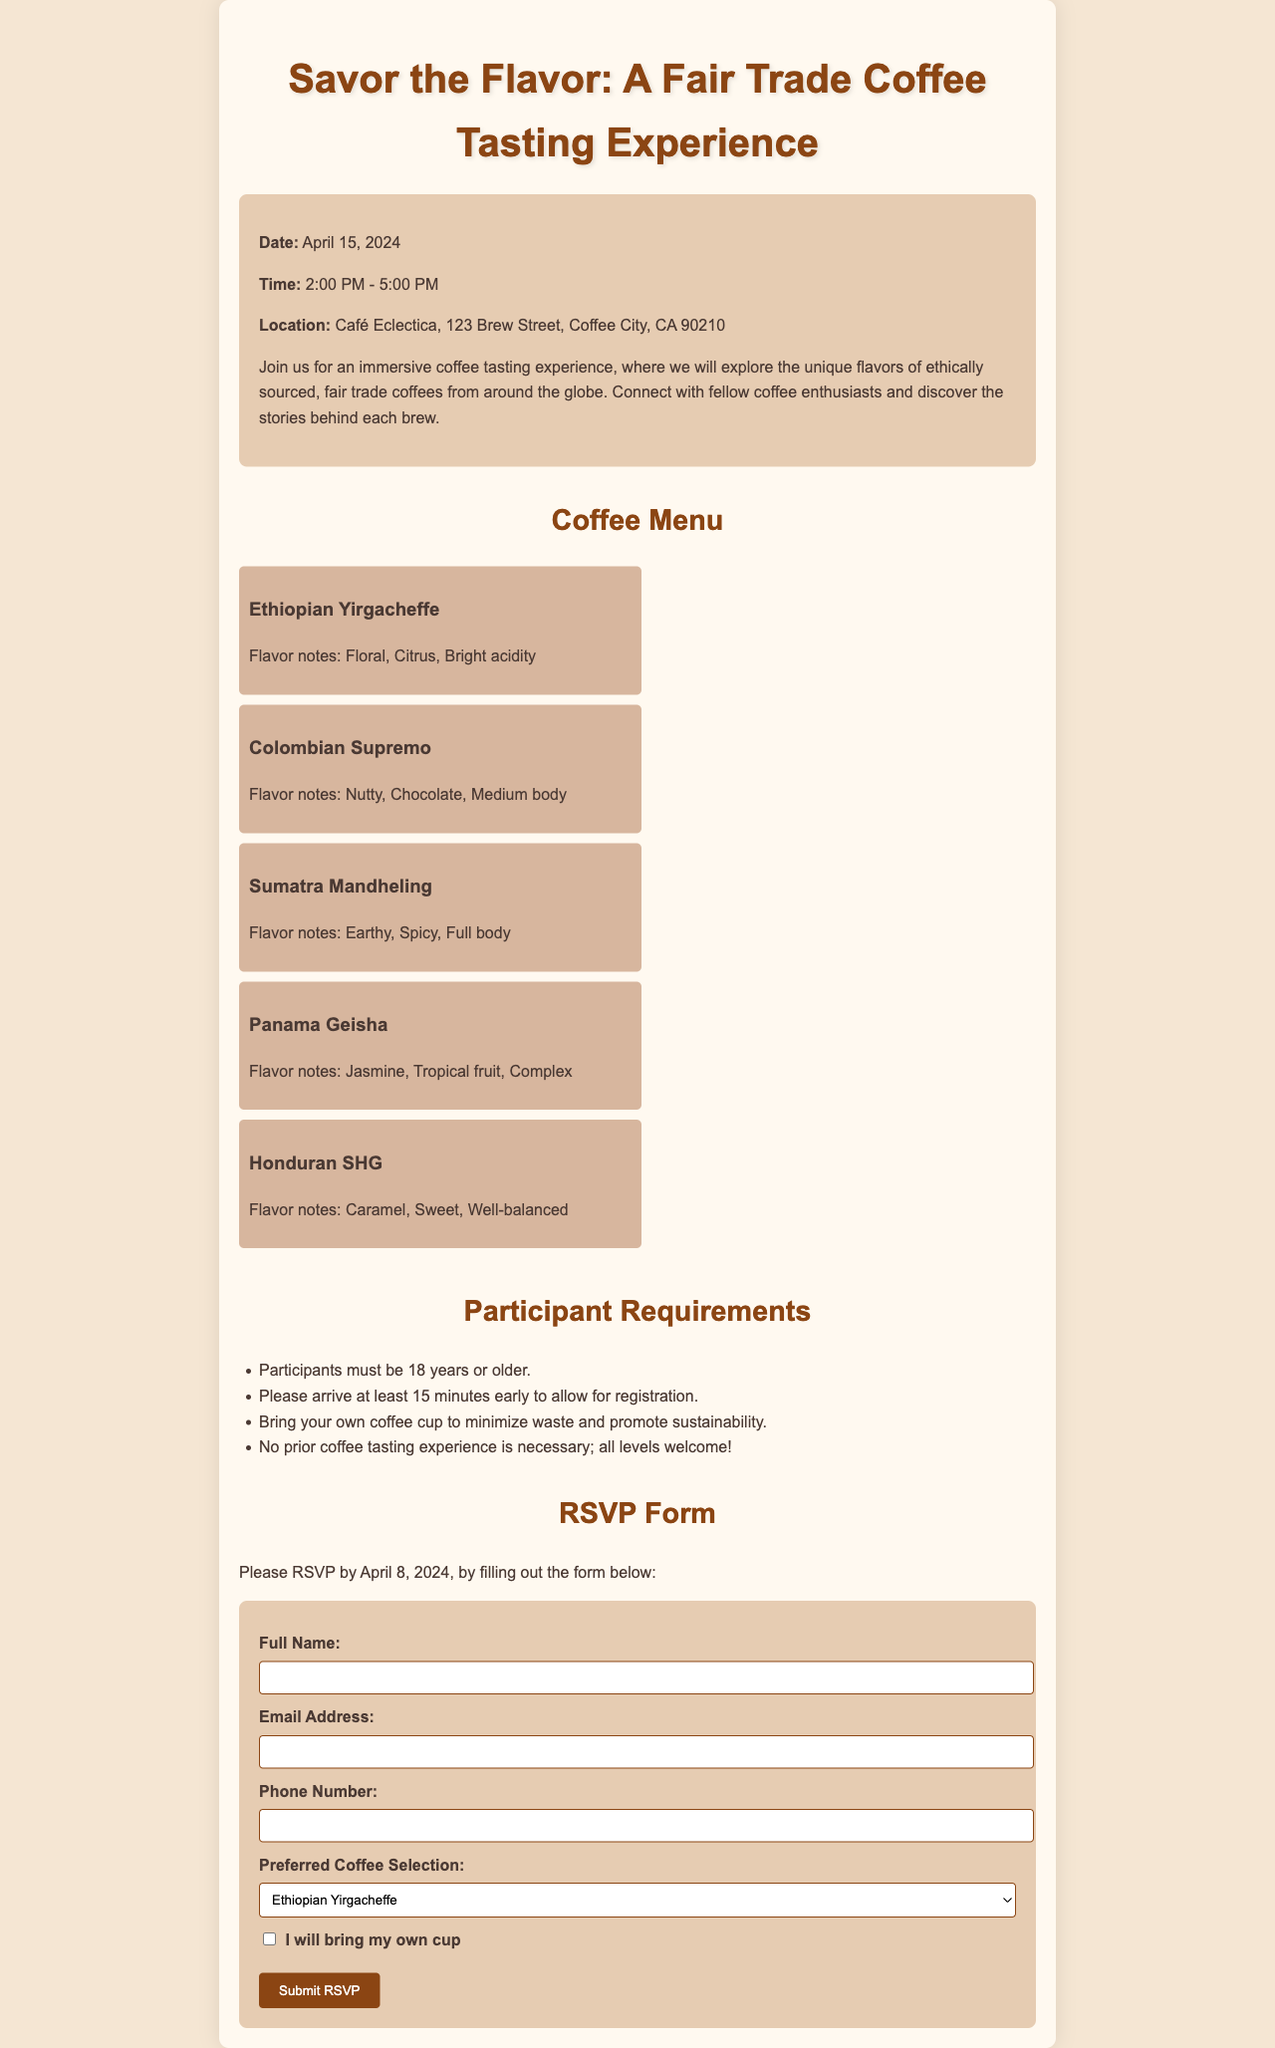What is the date of the coffee tasting event? The date of the event is mentioned directly in the document under event details.
Answer: April 15, 2024 What time does the coffee tasting experience start? The event time is specified in the document as part of the event details.
Answer: 2:00 PM What is the location of the event? The location is listed within the event details section of the document.
Answer: Café Eclectica, 123 Brew Street, Coffee City, CA 90210 How many coffee options are listed in the menu? The number of coffee items can be counted from the menu section in the document.
Answer: 5 What is one of the flavor notes for the Ethiopian Yirgacheffe coffee? Flavor notes can be found in the coffee menu section for each coffee type.
Answer: Floral What is required of participants in regards to their coffee cup? This requirement is specified in the participant requirements section of the document.
Answer: Bring your own coffee cup What is the deadline for RSVPing to the event? The RSVP deadline is explicitly stated in the RSVP form section of the document.
Answer: April 8, 2024 Are prior coffee tasting experiences necessary to participate? This is a requirement mentioned in the participant requirements of the document.
Answer: No What is the main theme of the event? The theme is suggested by the title and description of the event in the document.
Answer: Fair Trade Coffee Tasting Experience 